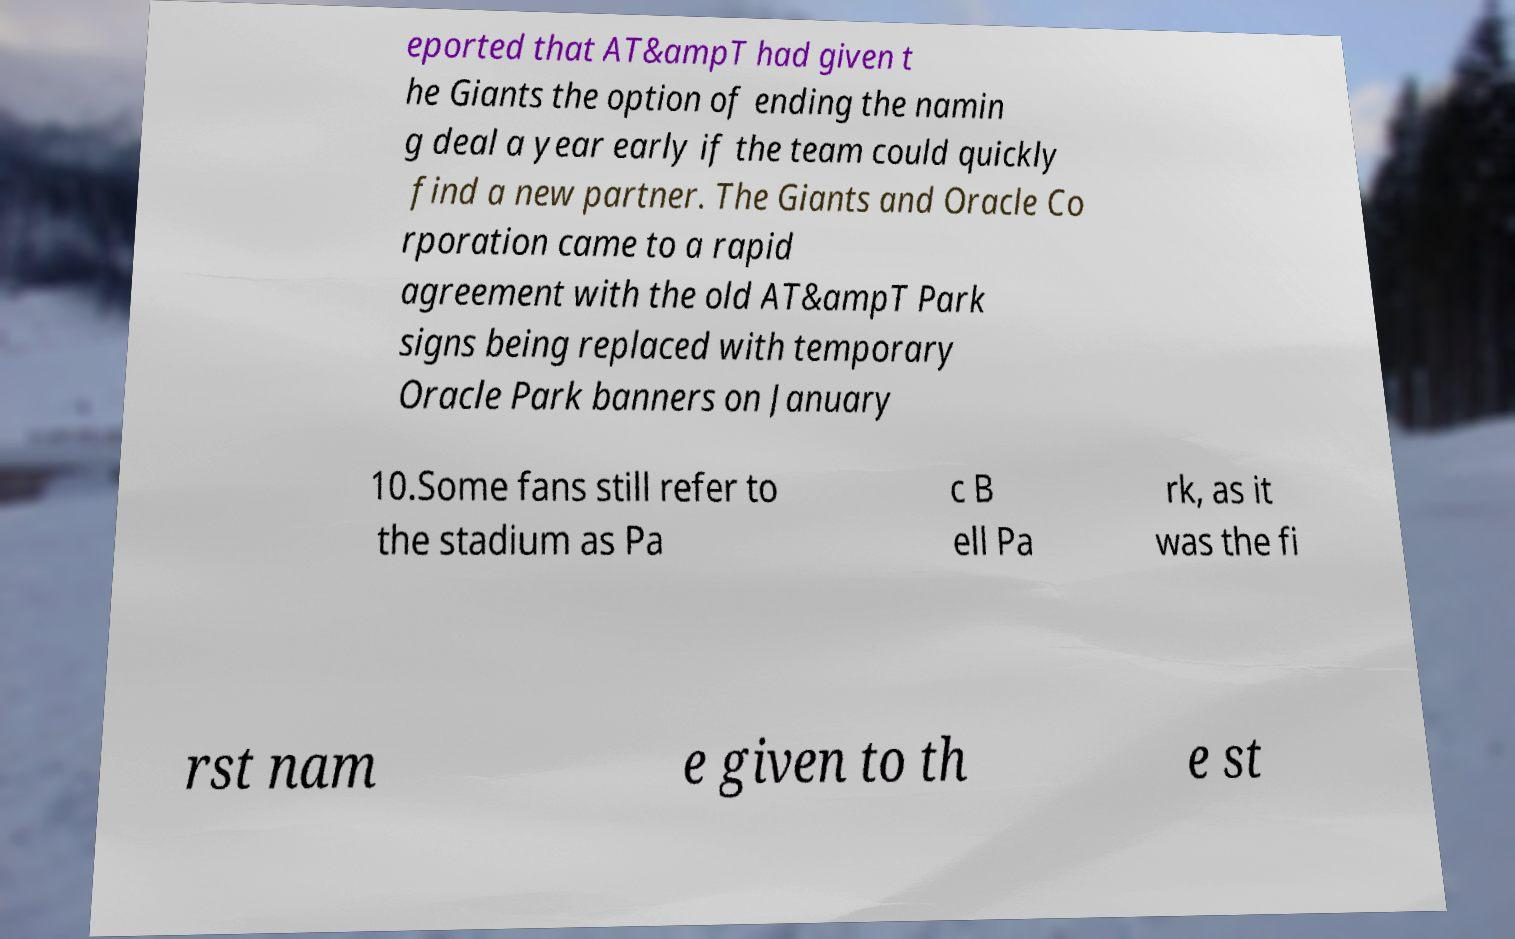What messages or text are displayed in this image? I need them in a readable, typed format. eported that AT&ampT had given t he Giants the option of ending the namin g deal a year early if the team could quickly find a new partner. The Giants and Oracle Co rporation came to a rapid agreement with the old AT&ampT Park signs being replaced with temporary Oracle Park banners on January 10.Some fans still refer to the stadium as Pa c B ell Pa rk, as it was the fi rst nam e given to th e st 